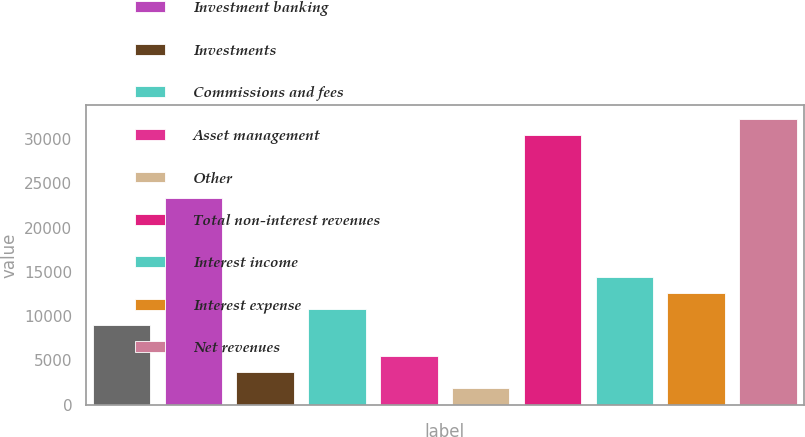<chart> <loc_0><loc_0><loc_500><loc_500><bar_chart><fcel>in millions<fcel>Investment banking<fcel>Investments<fcel>Commissions and fees<fcel>Asset management<fcel>Other<fcel>Total non-interest revenues<fcel>Interest income<fcel>Interest expense<fcel>Net revenues<nl><fcel>9043<fcel>23299<fcel>3697<fcel>10825<fcel>5479<fcel>1915<fcel>30427<fcel>14389<fcel>12607<fcel>32209<nl></chart> 